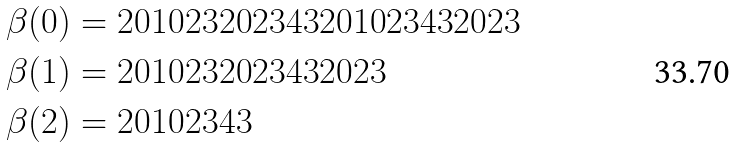<formula> <loc_0><loc_0><loc_500><loc_500>\beta ( 0 ) & = 2 0 1 0 2 3 2 0 2 3 4 3 2 0 1 0 2 3 4 3 2 0 2 3 \\ \beta ( 1 ) & = 2 0 1 0 2 3 2 0 2 3 4 3 2 0 2 3 \\ \beta ( 2 ) & = 2 0 1 0 2 3 4 3 \,</formula> 